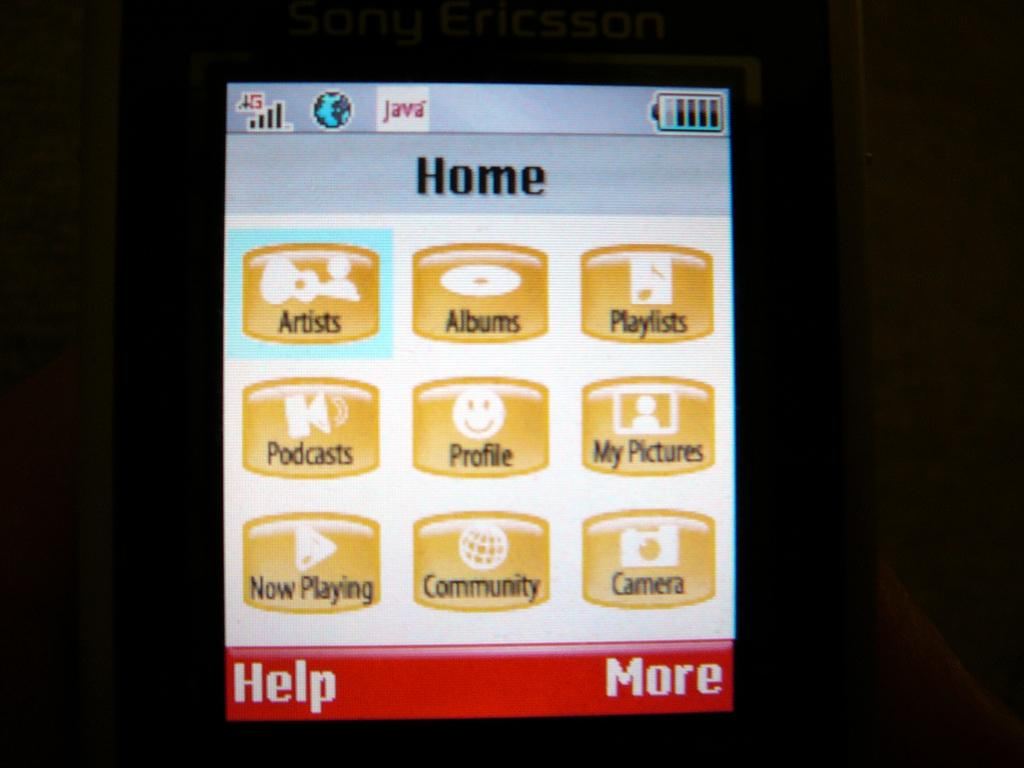<image>
Provide a brief description of the given image. The sipaly screen of a cellphone showing options for music playlists, podcasts and other media. 